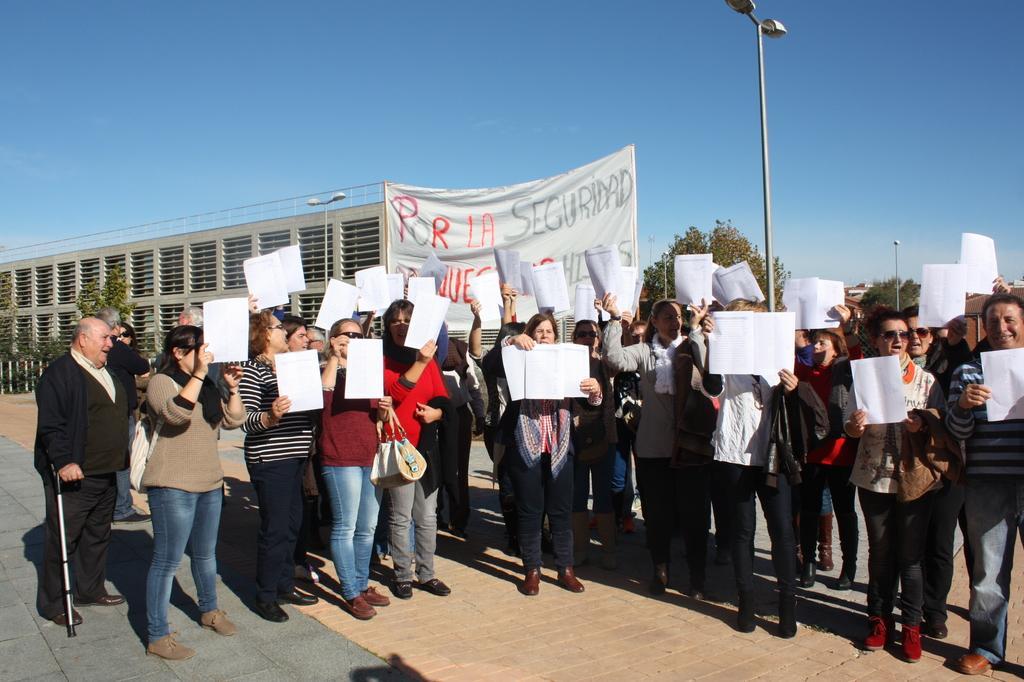How would you summarize this image in a sentence or two? In this image there are a few people standing and holding placards in their hands, in the background of the image there are trees, buildings and lamp posts. 